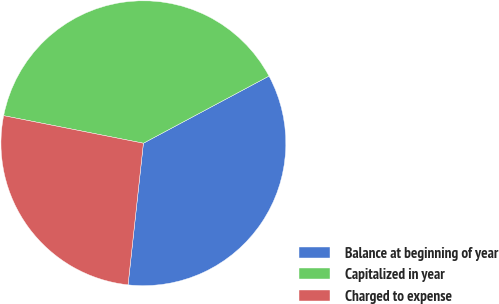Convert chart. <chart><loc_0><loc_0><loc_500><loc_500><pie_chart><fcel>Balance at beginning of year<fcel>Capitalized in year<fcel>Charged to expense<nl><fcel>34.53%<fcel>39.09%<fcel>26.38%<nl></chart> 